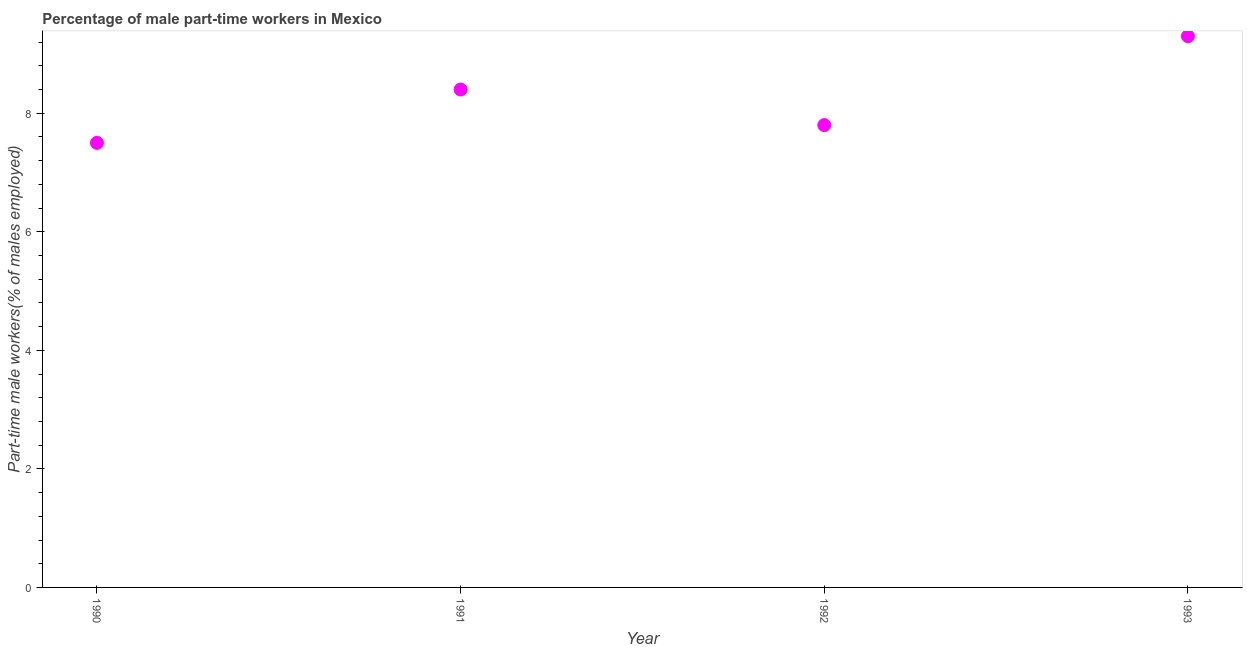What is the percentage of part-time male workers in 1991?
Your answer should be compact. 8.4. Across all years, what is the maximum percentage of part-time male workers?
Ensure brevity in your answer.  9.3. Across all years, what is the minimum percentage of part-time male workers?
Make the answer very short. 7.5. In which year was the percentage of part-time male workers maximum?
Your answer should be compact. 1993. In which year was the percentage of part-time male workers minimum?
Offer a terse response. 1990. What is the sum of the percentage of part-time male workers?
Provide a short and direct response. 33. What is the difference between the percentage of part-time male workers in 1990 and 1991?
Provide a succinct answer. -0.9. What is the average percentage of part-time male workers per year?
Give a very brief answer. 8.25. What is the median percentage of part-time male workers?
Provide a succinct answer. 8.1. In how many years, is the percentage of part-time male workers greater than 2 %?
Your answer should be compact. 4. Do a majority of the years between 1990 and 1991 (inclusive) have percentage of part-time male workers greater than 6.8 %?
Ensure brevity in your answer.  Yes. What is the ratio of the percentage of part-time male workers in 1991 to that in 1992?
Your answer should be very brief. 1.08. Is the percentage of part-time male workers in 1991 less than that in 1992?
Provide a succinct answer. No. Is the difference between the percentage of part-time male workers in 1991 and 1993 greater than the difference between any two years?
Provide a short and direct response. No. What is the difference between the highest and the second highest percentage of part-time male workers?
Offer a terse response. 0.9. What is the difference between the highest and the lowest percentage of part-time male workers?
Provide a succinct answer. 1.8. In how many years, is the percentage of part-time male workers greater than the average percentage of part-time male workers taken over all years?
Offer a terse response. 2. Does the percentage of part-time male workers monotonically increase over the years?
Your answer should be very brief. No. How many dotlines are there?
Keep it short and to the point. 1. What is the difference between two consecutive major ticks on the Y-axis?
Keep it short and to the point. 2. Does the graph contain any zero values?
Keep it short and to the point. No. Does the graph contain grids?
Your response must be concise. No. What is the title of the graph?
Offer a very short reply. Percentage of male part-time workers in Mexico. What is the label or title of the Y-axis?
Ensure brevity in your answer.  Part-time male workers(% of males employed). What is the Part-time male workers(% of males employed) in 1991?
Offer a terse response. 8.4. What is the Part-time male workers(% of males employed) in 1992?
Provide a short and direct response. 7.8. What is the Part-time male workers(% of males employed) in 1993?
Your answer should be compact. 9.3. What is the difference between the Part-time male workers(% of males employed) in 1990 and 1993?
Make the answer very short. -1.8. What is the difference between the Part-time male workers(% of males employed) in 1991 and 1992?
Ensure brevity in your answer.  0.6. What is the ratio of the Part-time male workers(% of males employed) in 1990 to that in 1991?
Ensure brevity in your answer.  0.89. What is the ratio of the Part-time male workers(% of males employed) in 1990 to that in 1992?
Ensure brevity in your answer.  0.96. What is the ratio of the Part-time male workers(% of males employed) in 1990 to that in 1993?
Your answer should be compact. 0.81. What is the ratio of the Part-time male workers(% of males employed) in 1991 to that in 1992?
Make the answer very short. 1.08. What is the ratio of the Part-time male workers(% of males employed) in 1991 to that in 1993?
Your response must be concise. 0.9. What is the ratio of the Part-time male workers(% of males employed) in 1992 to that in 1993?
Provide a short and direct response. 0.84. 